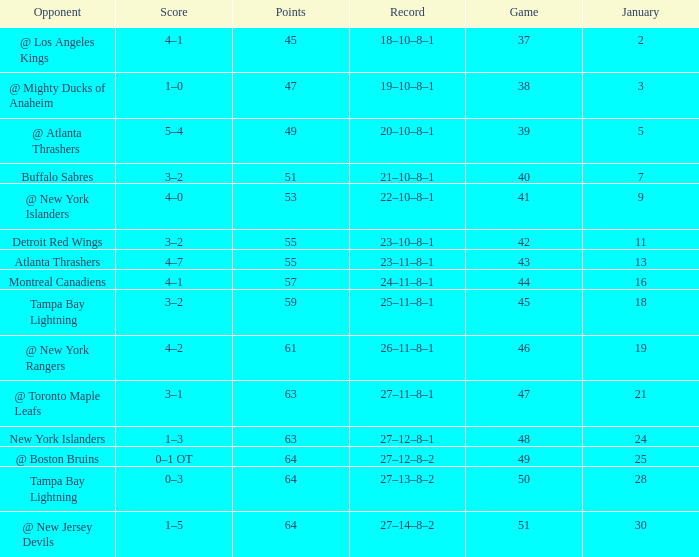How many Games have a Score of 5–4, and Points smaller than 49? 0.0. 